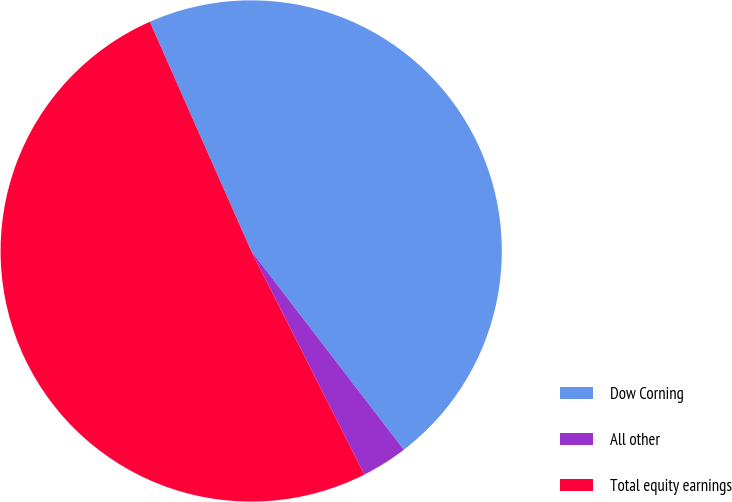<chart> <loc_0><loc_0><loc_500><loc_500><pie_chart><fcel>Dow Corning<fcel>All other<fcel>Total equity earnings<nl><fcel>46.21%<fcel>2.96%<fcel>50.83%<nl></chart> 